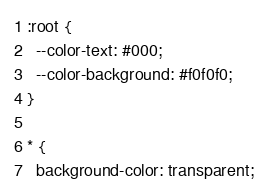Convert code to text. <code><loc_0><loc_0><loc_500><loc_500><_CSS_>:root {
  --color-text: #000;
  --color-background: #f0f0f0;
}

* {
  background-color: transparent;</code> 